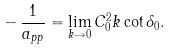<formula> <loc_0><loc_0><loc_500><loc_500>- \, \frac { 1 } { a _ { p p } } = \lim _ { k \rightarrow 0 } C _ { 0 } ^ { 2 } k \cot \delta _ { 0 } .</formula> 